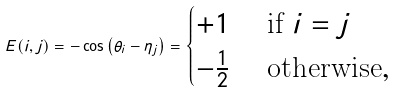Convert formula to latex. <formula><loc_0><loc_0><loc_500><loc_500>E ( i , j ) = - \cos \left ( \theta _ { i } - \eta _ { j } \right ) = \begin{cases} + 1 & \text {\ if $i=j$} \\ - \frac { 1 } { 2 } & \text {\ otherwise} , \end{cases}</formula> 